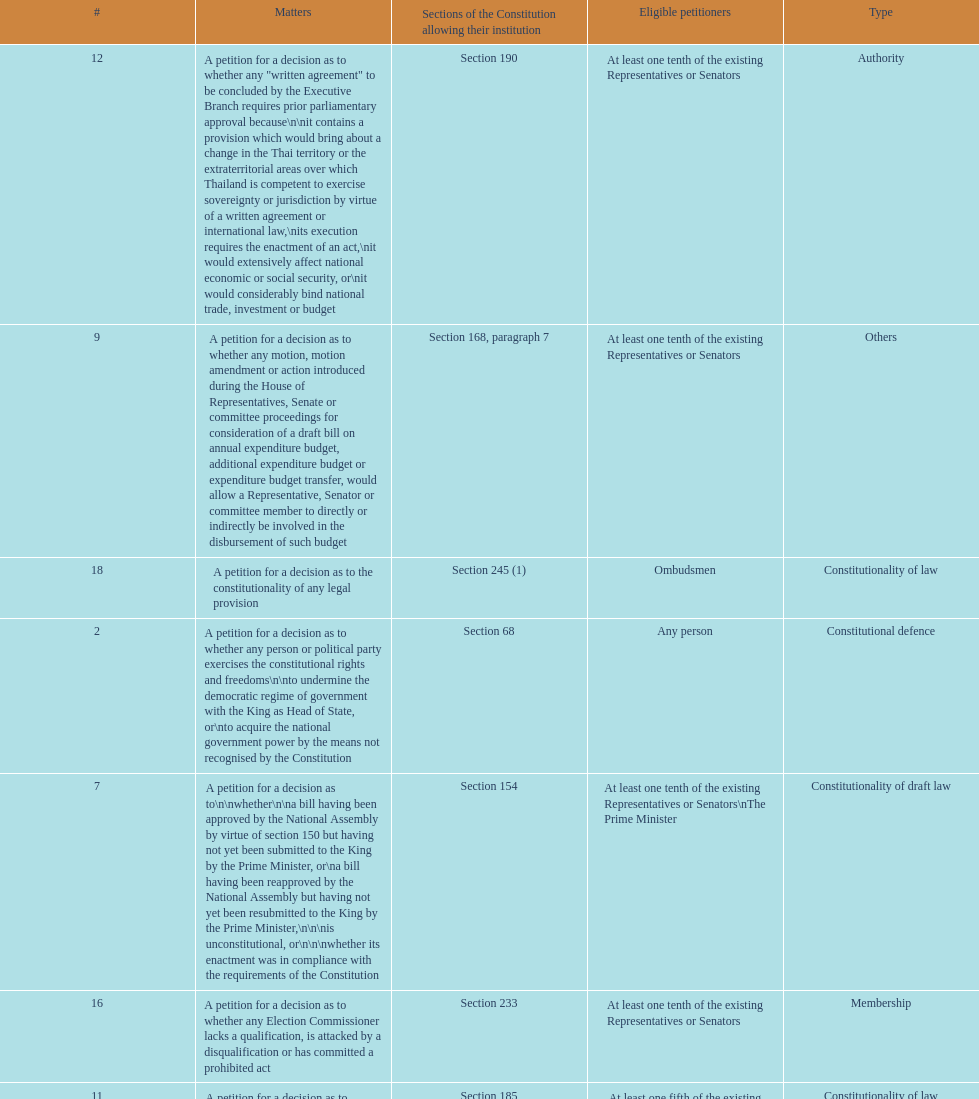Any person can petition matters 2 and 17. true or false? True. 